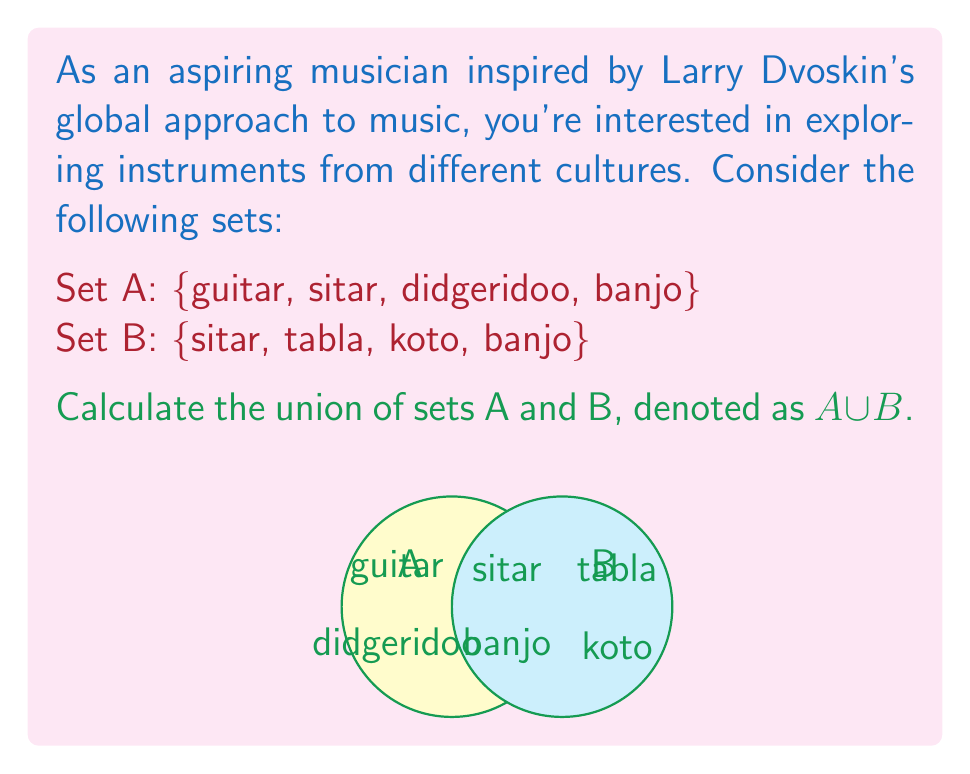What is the answer to this math problem? To calculate the union of two sets, we combine all unique elements from both sets. Let's approach this step-by-step:

1) First, let's list out the elements of each set:
   Set A: {guitar, sitar, didgeridoo, banjo}
   Set B: {sitar, tabla, koto, banjo}

2) Now, we'll create a new set that includes all unique elements from both sets:
   - Start with all elements from Set A: {guitar, sitar, didgeridoo, banjo}
   - Add any elements from Set B that aren't already included:
     - sitar is already included
     - tabla is new, so we add it
     - koto is new, so we add it
     - banjo is already included

3) The resulting union set $A \cup B$ contains all unique elements from both sets:
   $A \cup B = \{guitar, sitar, didgeridoo, banjo, tabla, koto\}$

4) We can verify that:
   - All elements from Set A are included
   - All elements from Set B are included
   - Duplicate elements (sitar and banjo) are only listed once

5) The number of elements in the union, denoted as $|A \cup B|$, is 6.

This diverse set of instruments reflects a global music perspective, combining Western (guitar, banjo), Indian (sitar, tabla), Australian (didgeridoo), and Japanese (koto) instruments, aligning with Larry Dvoskin's approach to music.
Answer: $A \cup B = \{guitar, sitar, didgeridoo, banjo, tabla, koto\}$ 